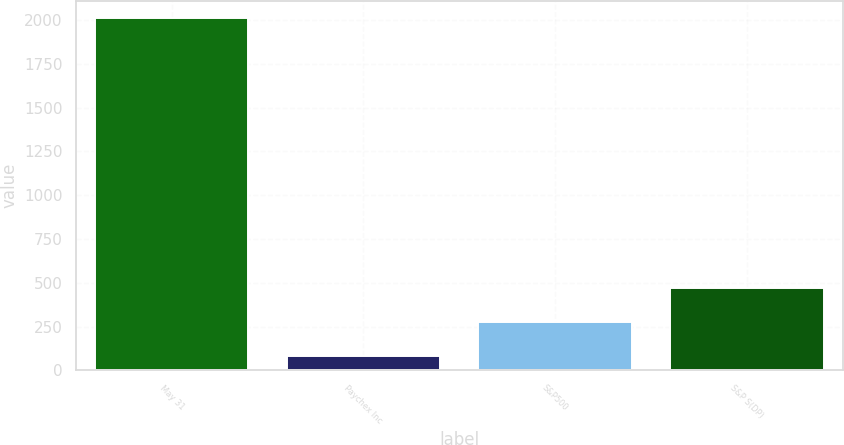Convert chart to OTSL. <chart><loc_0><loc_0><loc_500><loc_500><bar_chart><fcel>May 31<fcel>Paychex Inc<fcel>S&P500<fcel>S&P S(DP)<nl><fcel>2009<fcel>82.97<fcel>275.57<fcel>468.17<nl></chart> 